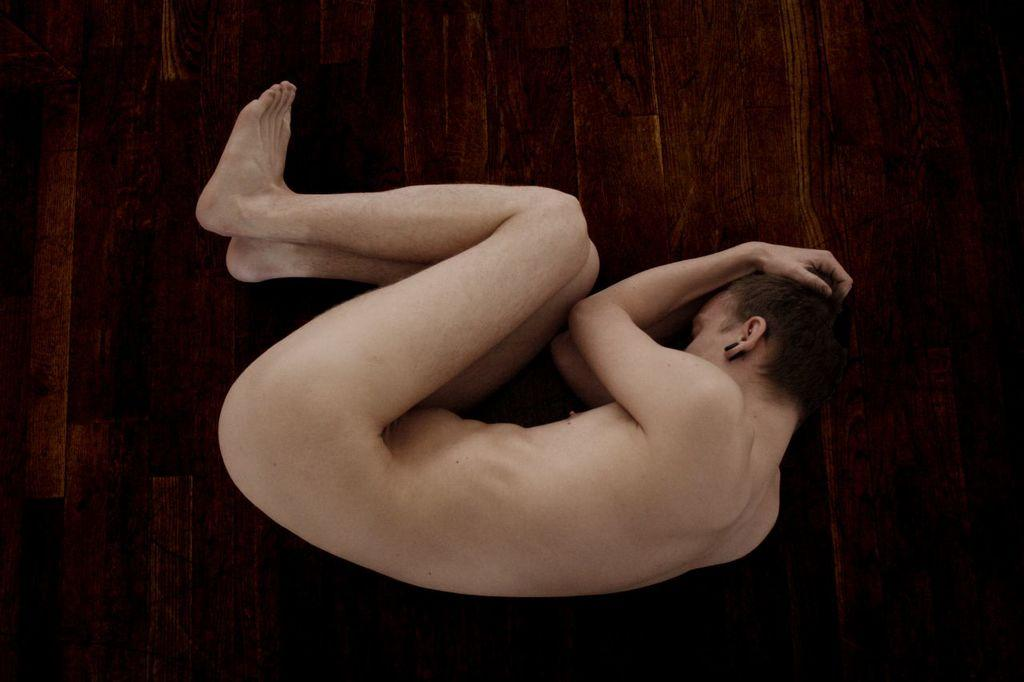What is happening in the image? There is a person in the image, and they are sleeping. Where is the person sleeping? The person is on a wooden floor. What type of plantation can be seen in the background of the image? There is no plantation visible in the image; it only shows a person sleeping on a wooden floor. 